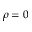<formula> <loc_0><loc_0><loc_500><loc_500>\rho = 0</formula> 